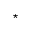<formula> <loc_0><loc_0><loc_500><loc_500>^ { * }</formula> 